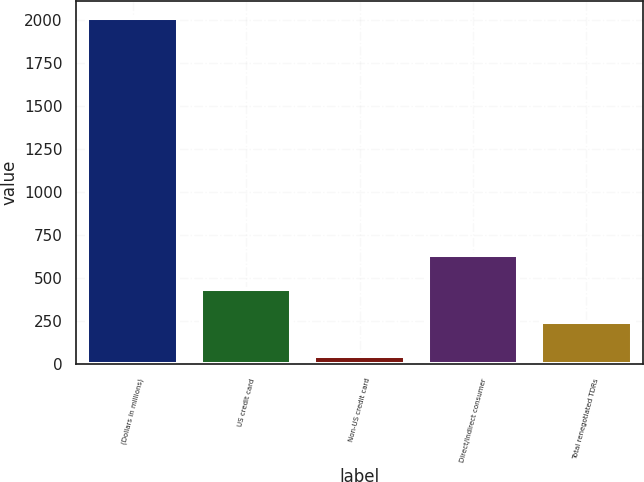Convert chart. <chart><loc_0><loc_0><loc_500><loc_500><bar_chart><fcel>(Dollars in millions)<fcel>US credit card<fcel>Non-US credit card<fcel>Direct/Indirect consumer<fcel>Total renegotiated TDRs<nl><fcel>2014<fcel>440.84<fcel>47.56<fcel>637.48<fcel>244.2<nl></chart> 